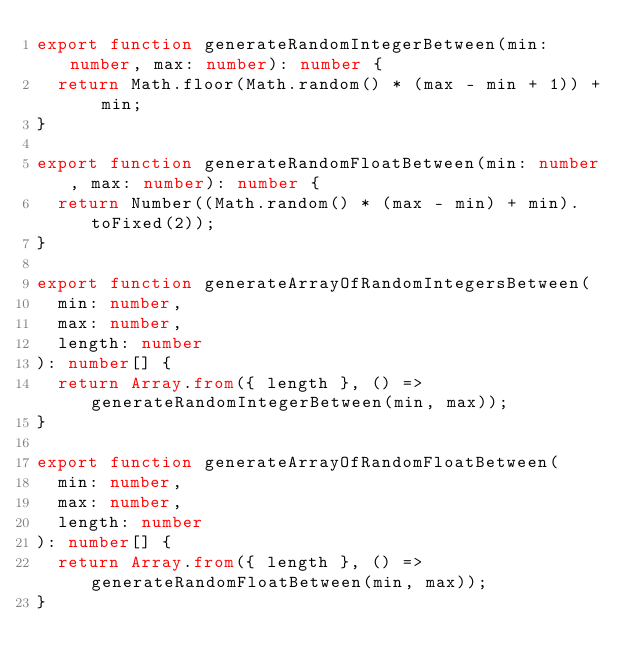Convert code to text. <code><loc_0><loc_0><loc_500><loc_500><_TypeScript_>export function generateRandomIntegerBetween(min: number, max: number): number {
  return Math.floor(Math.random() * (max - min + 1)) + min;
}

export function generateRandomFloatBetween(min: number, max: number): number {
  return Number((Math.random() * (max - min) + min).toFixed(2));
}

export function generateArrayOfRandomIntegersBetween(
  min: number,
  max: number,
  length: number
): number[] {
  return Array.from({ length }, () => generateRandomIntegerBetween(min, max));
}

export function generateArrayOfRandomFloatBetween(
  min: number,
  max: number,
  length: number
): number[] {
  return Array.from({ length }, () => generateRandomFloatBetween(min, max));
}
</code> 